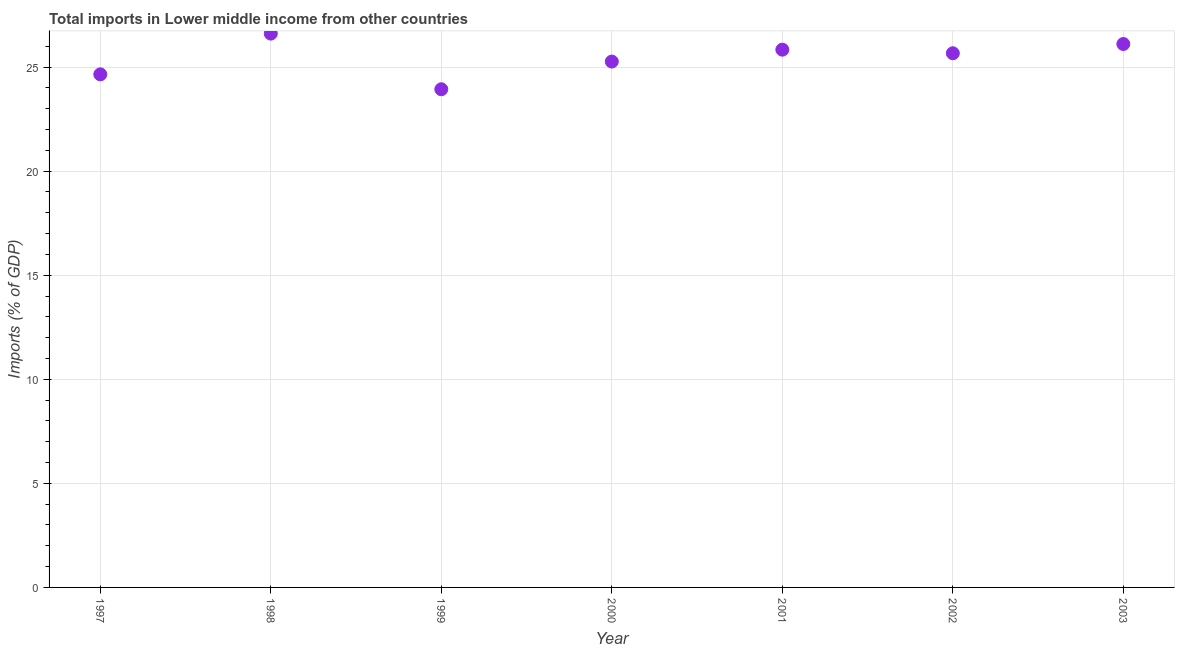What is the total imports in 1999?
Your answer should be very brief. 23.94. Across all years, what is the maximum total imports?
Your answer should be very brief. 26.61. Across all years, what is the minimum total imports?
Offer a terse response. 23.94. In which year was the total imports maximum?
Provide a short and direct response. 1998. What is the sum of the total imports?
Your answer should be compact. 178.08. What is the difference between the total imports in 1997 and 2002?
Your answer should be compact. -1.01. What is the average total imports per year?
Make the answer very short. 25.44. What is the median total imports?
Ensure brevity in your answer.  25.67. What is the ratio of the total imports in 1998 to that in 2001?
Your answer should be compact. 1.03. What is the difference between the highest and the second highest total imports?
Ensure brevity in your answer.  0.5. What is the difference between the highest and the lowest total imports?
Your answer should be compact. 2.67. Does the total imports monotonically increase over the years?
Offer a terse response. No. How many dotlines are there?
Offer a very short reply. 1. Are the values on the major ticks of Y-axis written in scientific E-notation?
Make the answer very short. No. Does the graph contain any zero values?
Provide a short and direct response. No. Does the graph contain grids?
Keep it short and to the point. Yes. What is the title of the graph?
Provide a succinct answer. Total imports in Lower middle income from other countries. What is the label or title of the X-axis?
Provide a succinct answer. Year. What is the label or title of the Y-axis?
Provide a short and direct response. Imports (% of GDP). What is the Imports (% of GDP) in 1997?
Keep it short and to the point. 24.65. What is the Imports (% of GDP) in 1998?
Ensure brevity in your answer.  26.61. What is the Imports (% of GDP) in 1999?
Your answer should be compact. 23.94. What is the Imports (% of GDP) in 2000?
Make the answer very short. 25.27. What is the Imports (% of GDP) in 2001?
Your answer should be very brief. 25.84. What is the Imports (% of GDP) in 2002?
Your answer should be very brief. 25.67. What is the Imports (% of GDP) in 2003?
Offer a terse response. 26.11. What is the difference between the Imports (% of GDP) in 1997 and 1998?
Make the answer very short. -1.96. What is the difference between the Imports (% of GDP) in 1997 and 1999?
Make the answer very short. 0.72. What is the difference between the Imports (% of GDP) in 1997 and 2000?
Give a very brief answer. -0.61. What is the difference between the Imports (% of GDP) in 1997 and 2001?
Ensure brevity in your answer.  -1.19. What is the difference between the Imports (% of GDP) in 1997 and 2002?
Provide a short and direct response. -1.01. What is the difference between the Imports (% of GDP) in 1997 and 2003?
Your answer should be very brief. -1.46. What is the difference between the Imports (% of GDP) in 1998 and 1999?
Your answer should be very brief. 2.67. What is the difference between the Imports (% of GDP) in 1998 and 2000?
Provide a short and direct response. 1.34. What is the difference between the Imports (% of GDP) in 1998 and 2001?
Give a very brief answer. 0.77. What is the difference between the Imports (% of GDP) in 1998 and 2002?
Keep it short and to the point. 0.94. What is the difference between the Imports (% of GDP) in 1998 and 2003?
Your answer should be very brief. 0.5. What is the difference between the Imports (% of GDP) in 1999 and 2000?
Your answer should be compact. -1.33. What is the difference between the Imports (% of GDP) in 1999 and 2001?
Ensure brevity in your answer.  -1.9. What is the difference between the Imports (% of GDP) in 1999 and 2002?
Your answer should be very brief. -1.73. What is the difference between the Imports (% of GDP) in 1999 and 2003?
Provide a succinct answer. -2.17. What is the difference between the Imports (% of GDP) in 2000 and 2001?
Ensure brevity in your answer.  -0.57. What is the difference between the Imports (% of GDP) in 2000 and 2002?
Make the answer very short. -0.4. What is the difference between the Imports (% of GDP) in 2000 and 2003?
Keep it short and to the point. -0.84. What is the difference between the Imports (% of GDP) in 2001 and 2002?
Your response must be concise. 0.17. What is the difference between the Imports (% of GDP) in 2001 and 2003?
Your answer should be compact. -0.27. What is the difference between the Imports (% of GDP) in 2002 and 2003?
Offer a terse response. -0.44. What is the ratio of the Imports (% of GDP) in 1997 to that in 1998?
Provide a short and direct response. 0.93. What is the ratio of the Imports (% of GDP) in 1997 to that in 1999?
Ensure brevity in your answer.  1.03. What is the ratio of the Imports (% of GDP) in 1997 to that in 2000?
Keep it short and to the point. 0.98. What is the ratio of the Imports (% of GDP) in 1997 to that in 2001?
Make the answer very short. 0.95. What is the ratio of the Imports (% of GDP) in 1997 to that in 2002?
Make the answer very short. 0.96. What is the ratio of the Imports (% of GDP) in 1997 to that in 2003?
Provide a short and direct response. 0.94. What is the ratio of the Imports (% of GDP) in 1998 to that in 1999?
Your response must be concise. 1.11. What is the ratio of the Imports (% of GDP) in 1998 to that in 2000?
Your answer should be compact. 1.05. What is the ratio of the Imports (% of GDP) in 1998 to that in 2002?
Your response must be concise. 1.04. What is the ratio of the Imports (% of GDP) in 1998 to that in 2003?
Your answer should be very brief. 1.02. What is the ratio of the Imports (% of GDP) in 1999 to that in 2000?
Your response must be concise. 0.95. What is the ratio of the Imports (% of GDP) in 1999 to that in 2001?
Provide a short and direct response. 0.93. What is the ratio of the Imports (% of GDP) in 1999 to that in 2002?
Your answer should be compact. 0.93. What is the ratio of the Imports (% of GDP) in 1999 to that in 2003?
Make the answer very short. 0.92. What is the ratio of the Imports (% of GDP) in 2001 to that in 2002?
Your response must be concise. 1.01. What is the ratio of the Imports (% of GDP) in 2001 to that in 2003?
Make the answer very short. 0.99. 